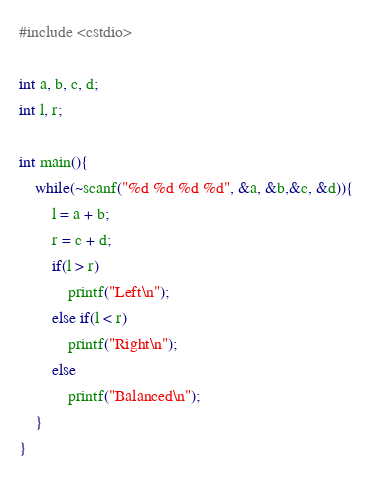<code> <loc_0><loc_0><loc_500><loc_500><_C++_>#include <cstdio>

int a, b, c, d;
int l, r;

int main(){
	while(~scanf("%d %d %d %d", &a, &b,&c, &d)){
		l = a + b;
		r = c + d;
		if(l > r)
			printf("Left\n");
		else if(l < r)
			printf("Right\n");
		else
			printf("Balanced\n");
	}
}</code> 